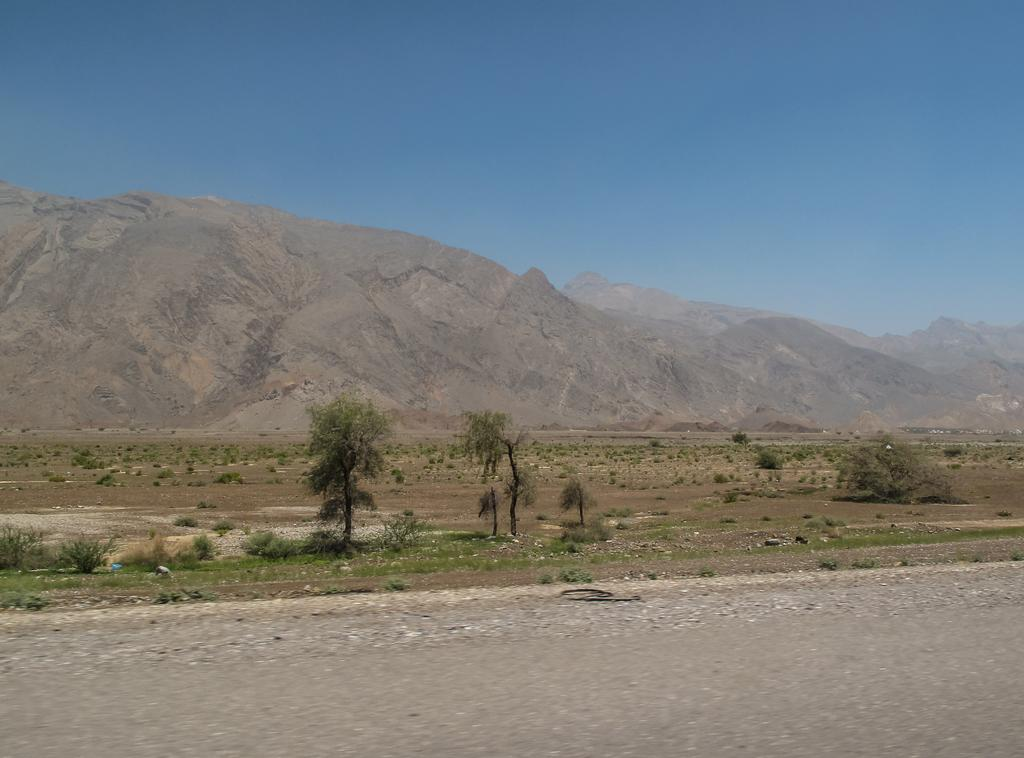What type of natural elements can be seen in the image? There are trees and plants in the image. What can be seen in the distance in the image? There are hills visible in the background of the image. Where is the boat located in the image? There is no boat present in the image. What type of zipper can be seen on the trees in the image? There are no zippers present on the trees in the image, as trees do not have zippers. 